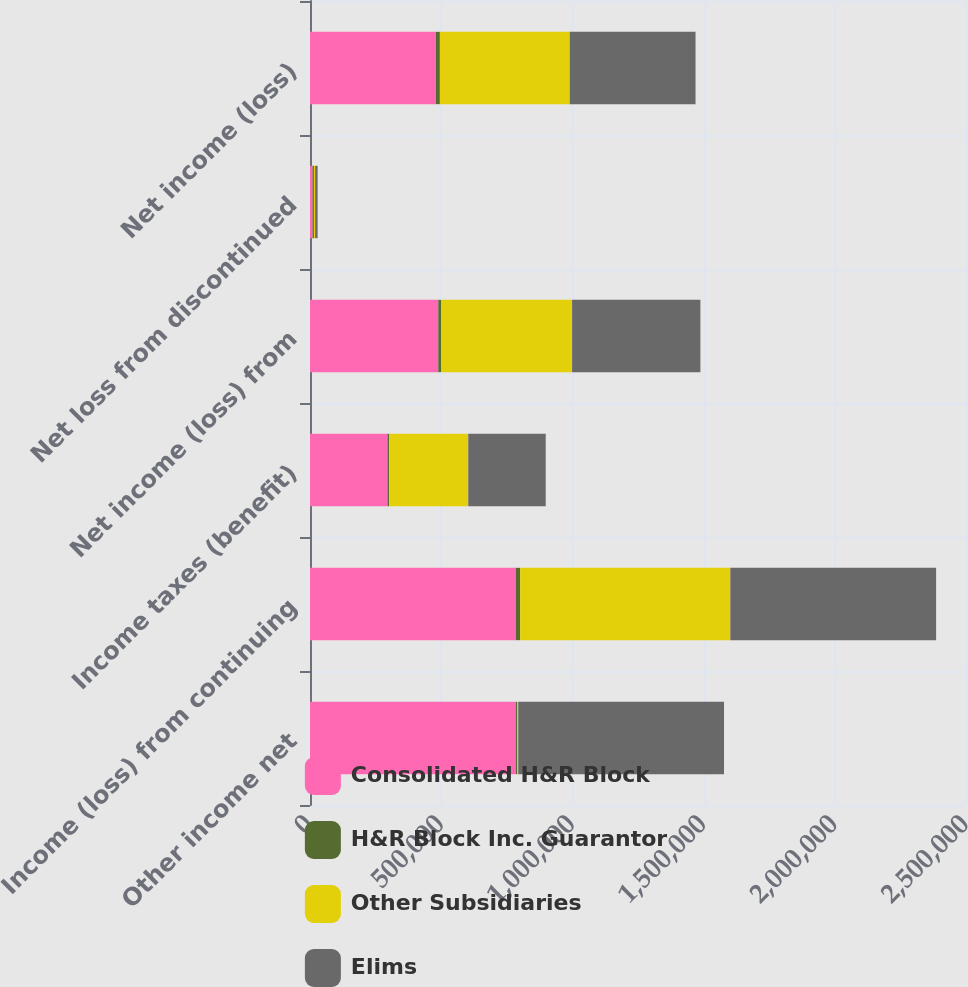Convert chart to OTSL. <chart><loc_0><loc_0><loc_500><loc_500><stacked_bar_chart><ecel><fcel>Other income net<fcel>Income (loss) from continuing<fcel>Income taxes (benefit)<fcel>Net income (loss) from<fcel>Net loss from discontinued<fcel>Net income (loss)<nl><fcel>Consolidated H&R Block<fcel>784135<fcel>784135<fcel>295189<fcel>488946<fcel>9704<fcel>479242<nl><fcel>H&R Block Inc. Guarantor<fcel>5644<fcel>16843<fcel>6368<fcel>10475<fcel>5276<fcel>15751<nl><fcel>Other Subsidiaries<fcel>3771<fcel>800978<fcel>301557<fcel>499421<fcel>4428<fcel>494993<nl><fcel>Elims<fcel>784252<fcel>784135<fcel>295189<fcel>488946<fcel>9704<fcel>479242<nl></chart> 